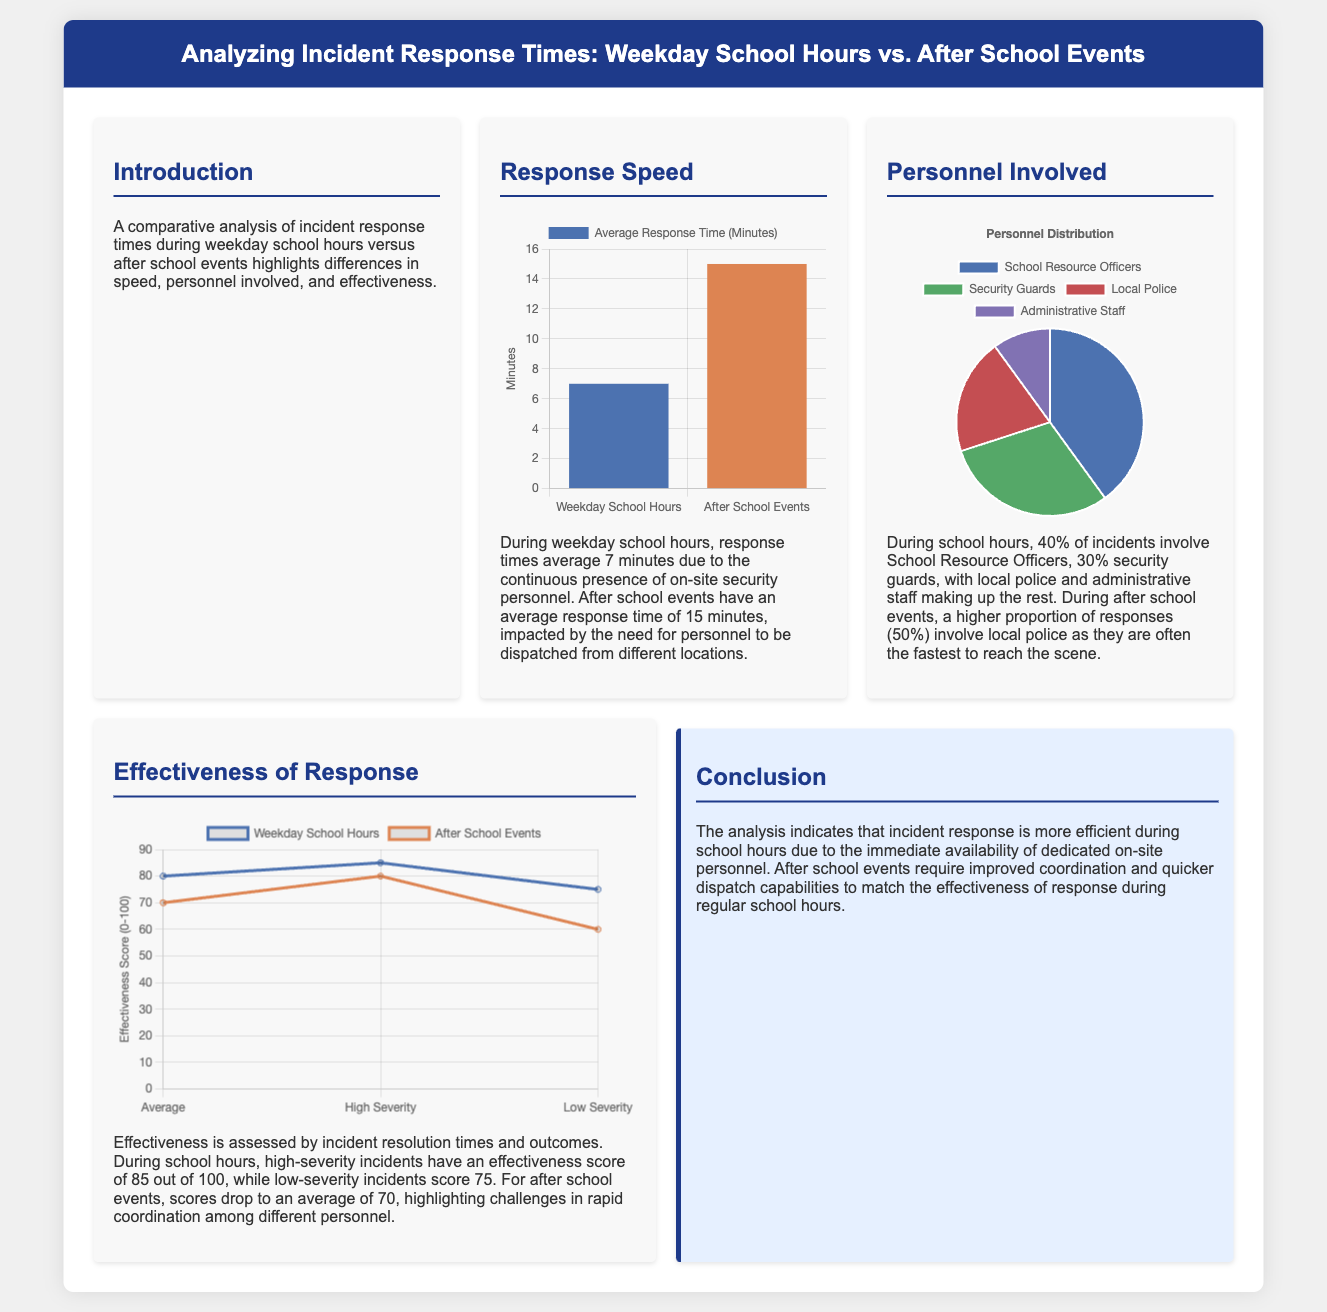what is the average response time during weekday school hours? The average response time during weekday school hours is stated in the document as 7 minutes.
Answer: 7 minutes what percentage of incidents involve School Resource Officers during school hours? The document indicates that 40% of incidents during school hours involve School Resource Officers.
Answer: 40% what is the effectiveness score for high-severity incidents during school hours? The effectiveness score for high-severity incidents during school hours is provided as 85 out of 100.
Answer: 85 what is the average response time for after school events? The average response time for after school events is mentioned as 15 minutes.
Answer: 15 minutes which personnel has the highest involvement during after school events? The document specifies that local police have the highest involvement at 50% during after school events.
Answer: local police what is the effectiveness score for low-severity incidents during after school events? The score for low-severity incidents during after school events is mentioned as 60 out of 100.
Answer: 60 how does the effectiveness score for weekday school hours compare to after school events? The document highlights that the effectiveness scores during school hours are generally higher than those for after school events, indicating better performance during school hours.
Answer: higher what is the title of the document? The title of the document is found at the top and is "Analyzing Incident Response Times: Weekday School Hours vs. After School Events."
Answer: Analyzing Incident Response Times: Weekday School Hours vs. After School Events what is the main challenge identified for after school events? The document points out that the main challenge for after school events is the coordination and quicker dispatch capabilities.
Answer: coordination and quicker dispatch capabilities 